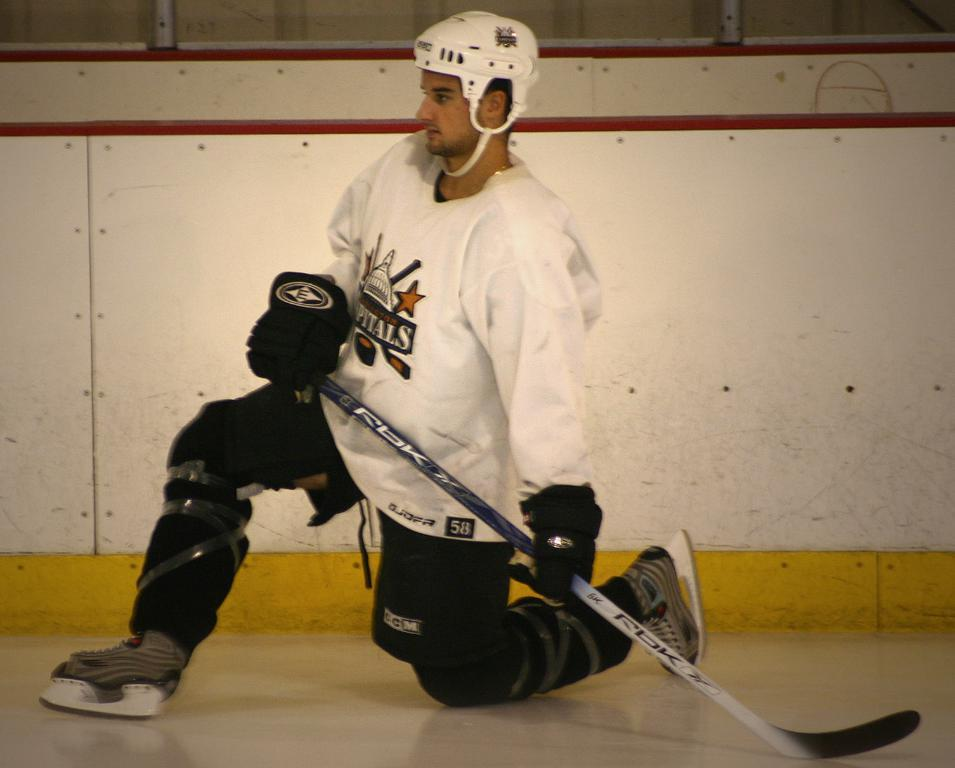What activity is the person in the image engaged in? The person is playing ice hockey in the image. Where is the person located in the image? The person is in the center of the image. What can be seen in the background of the image? There is a well in the background of the image. What color is the person's helmet? The person is wearing a white helmet. What color is the person's shirt? The person is wearing a white shirt. Can you see any pencils being used by the person in the image? There are no pencils visible in the image; the person is playing ice hockey. What type of tooth is visible in the image? There are no teeth or tooth-related objects present in the image. 